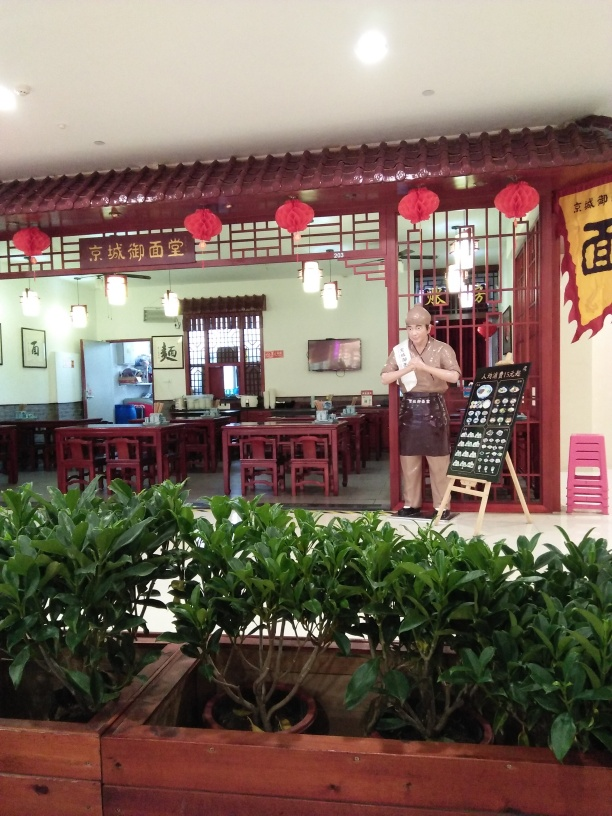What can be inferred about the cultural or historical significance of the decor in this restaurant? The decor in the restaurant draws heavily from traditional Chinese cultural motifs, which often evoke a sense of history and heritage. The use of calligraphy artworks suggests reverence for literary arts, a vital aspect of Chinese culture, while the red lanterns may indicate the importance of tradition, as they are commonly associated with festivals and celebratory occasions. The overall design likely aims to create a nostalgic atmosphere that pays homage to historical Chinese styles and practices.  Can the attire of the individual give us any clues about the type of service or atmosphere that this place has? The individual's attire, including an apron, suggests a hands-on approach to service and perhaps a family-run or intimate feel to the establishment. This attire is practical for staff involved in serving food and drinks, and it conveys a message of simplicity and focus on the dining experience. It may also imply an informal, homely atmosphere where guests can relax and enjoy their meal in a comfortable, traditional setting. 